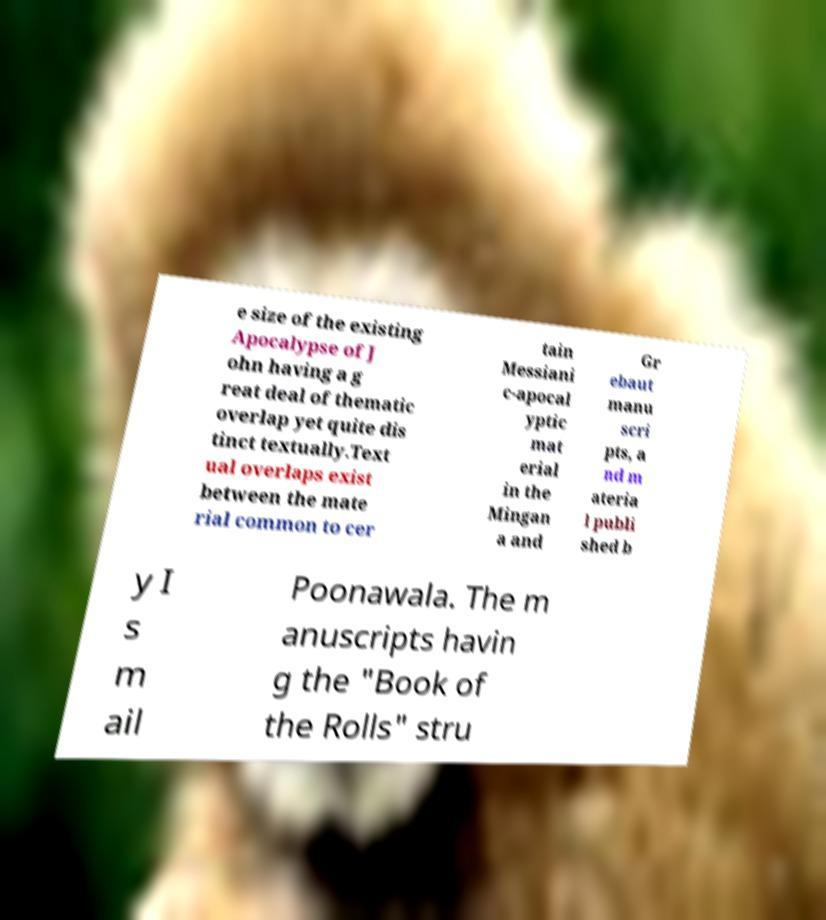Can you read and provide the text displayed in the image?This photo seems to have some interesting text. Can you extract and type it out for me? e size of the existing Apocalypse of J ohn having a g reat deal of thematic overlap yet quite dis tinct textually.Text ual overlaps exist between the mate rial common to cer tain Messiani c-apocal yptic mat erial in the Mingan a and Gr ebaut manu scri pts, a nd m ateria l publi shed b y I s m ail Poonawala. The m anuscripts havin g the "Book of the Rolls" stru 